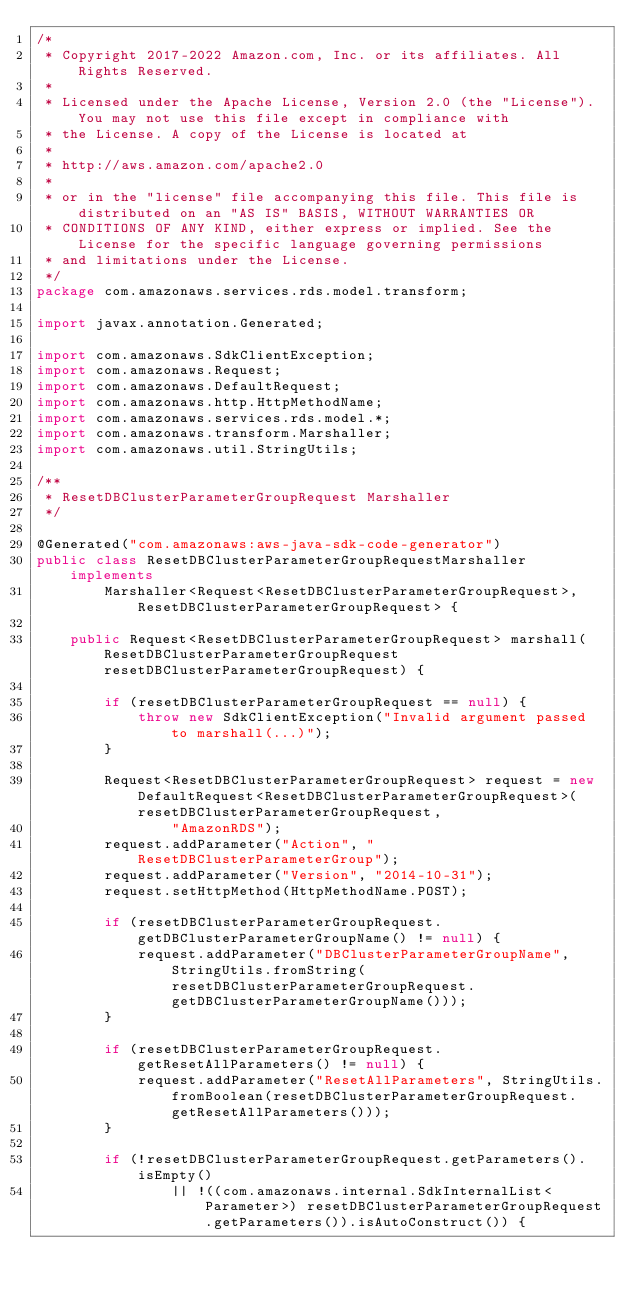<code> <loc_0><loc_0><loc_500><loc_500><_Java_>/*
 * Copyright 2017-2022 Amazon.com, Inc. or its affiliates. All Rights Reserved.
 * 
 * Licensed under the Apache License, Version 2.0 (the "License"). You may not use this file except in compliance with
 * the License. A copy of the License is located at
 * 
 * http://aws.amazon.com/apache2.0
 * 
 * or in the "license" file accompanying this file. This file is distributed on an "AS IS" BASIS, WITHOUT WARRANTIES OR
 * CONDITIONS OF ANY KIND, either express or implied. See the License for the specific language governing permissions
 * and limitations under the License.
 */
package com.amazonaws.services.rds.model.transform;

import javax.annotation.Generated;

import com.amazonaws.SdkClientException;
import com.amazonaws.Request;
import com.amazonaws.DefaultRequest;
import com.amazonaws.http.HttpMethodName;
import com.amazonaws.services.rds.model.*;
import com.amazonaws.transform.Marshaller;
import com.amazonaws.util.StringUtils;

/**
 * ResetDBClusterParameterGroupRequest Marshaller
 */

@Generated("com.amazonaws:aws-java-sdk-code-generator")
public class ResetDBClusterParameterGroupRequestMarshaller implements
        Marshaller<Request<ResetDBClusterParameterGroupRequest>, ResetDBClusterParameterGroupRequest> {

    public Request<ResetDBClusterParameterGroupRequest> marshall(ResetDBClusterParameterGroupRequest resetDBClusterParameterGroupRequest) {

        if (resetDBClusterParameterGroupRequest == null) {
            throw new SdkClientException("Invalid argument passed to marshall(...)");
        }

        Request<ResetDBClusterParameterGroupRequest> request = new DefaultRequest<ResetDBClusterParameterGroupRequest>(resetDBClusterParameterGroupRequest,
                "AmazonRDS");
        request.addParameter("Action", "ResetDBClusterParameterGroup");
        request.addParameter("Version", "2014-10-31");
        request.setHttpMethod(HttpMethodName.POST);

        if (resetDBClusterParameterGroupRequest.getDBClusterParameterGroupName() != null) {
            request.addParameter("DBClusterParameterGroupName", StringUtils.fromString(resetDBClusterParameterGroupRequest.getDBClusterParameterGroupName()));
        }

        if (resetDBClusterParameterGroupRequest.getResetAllParameters() != null) {
            request.addParameter("ResetAllParameters", StringUtils.fromBoolean(resetDBClusterParameterGroupRequest.getResetAllParameters()));
        }

        if (!resetDBClusterParameterGroupRequest.getParameters().isEmpty()
                || !((com.amazonaws.internal.SdkInternalList<Parameter>) resetDBClusterParameterGroupRequest.getParameters()).isAutoConstruct()) {</code> 